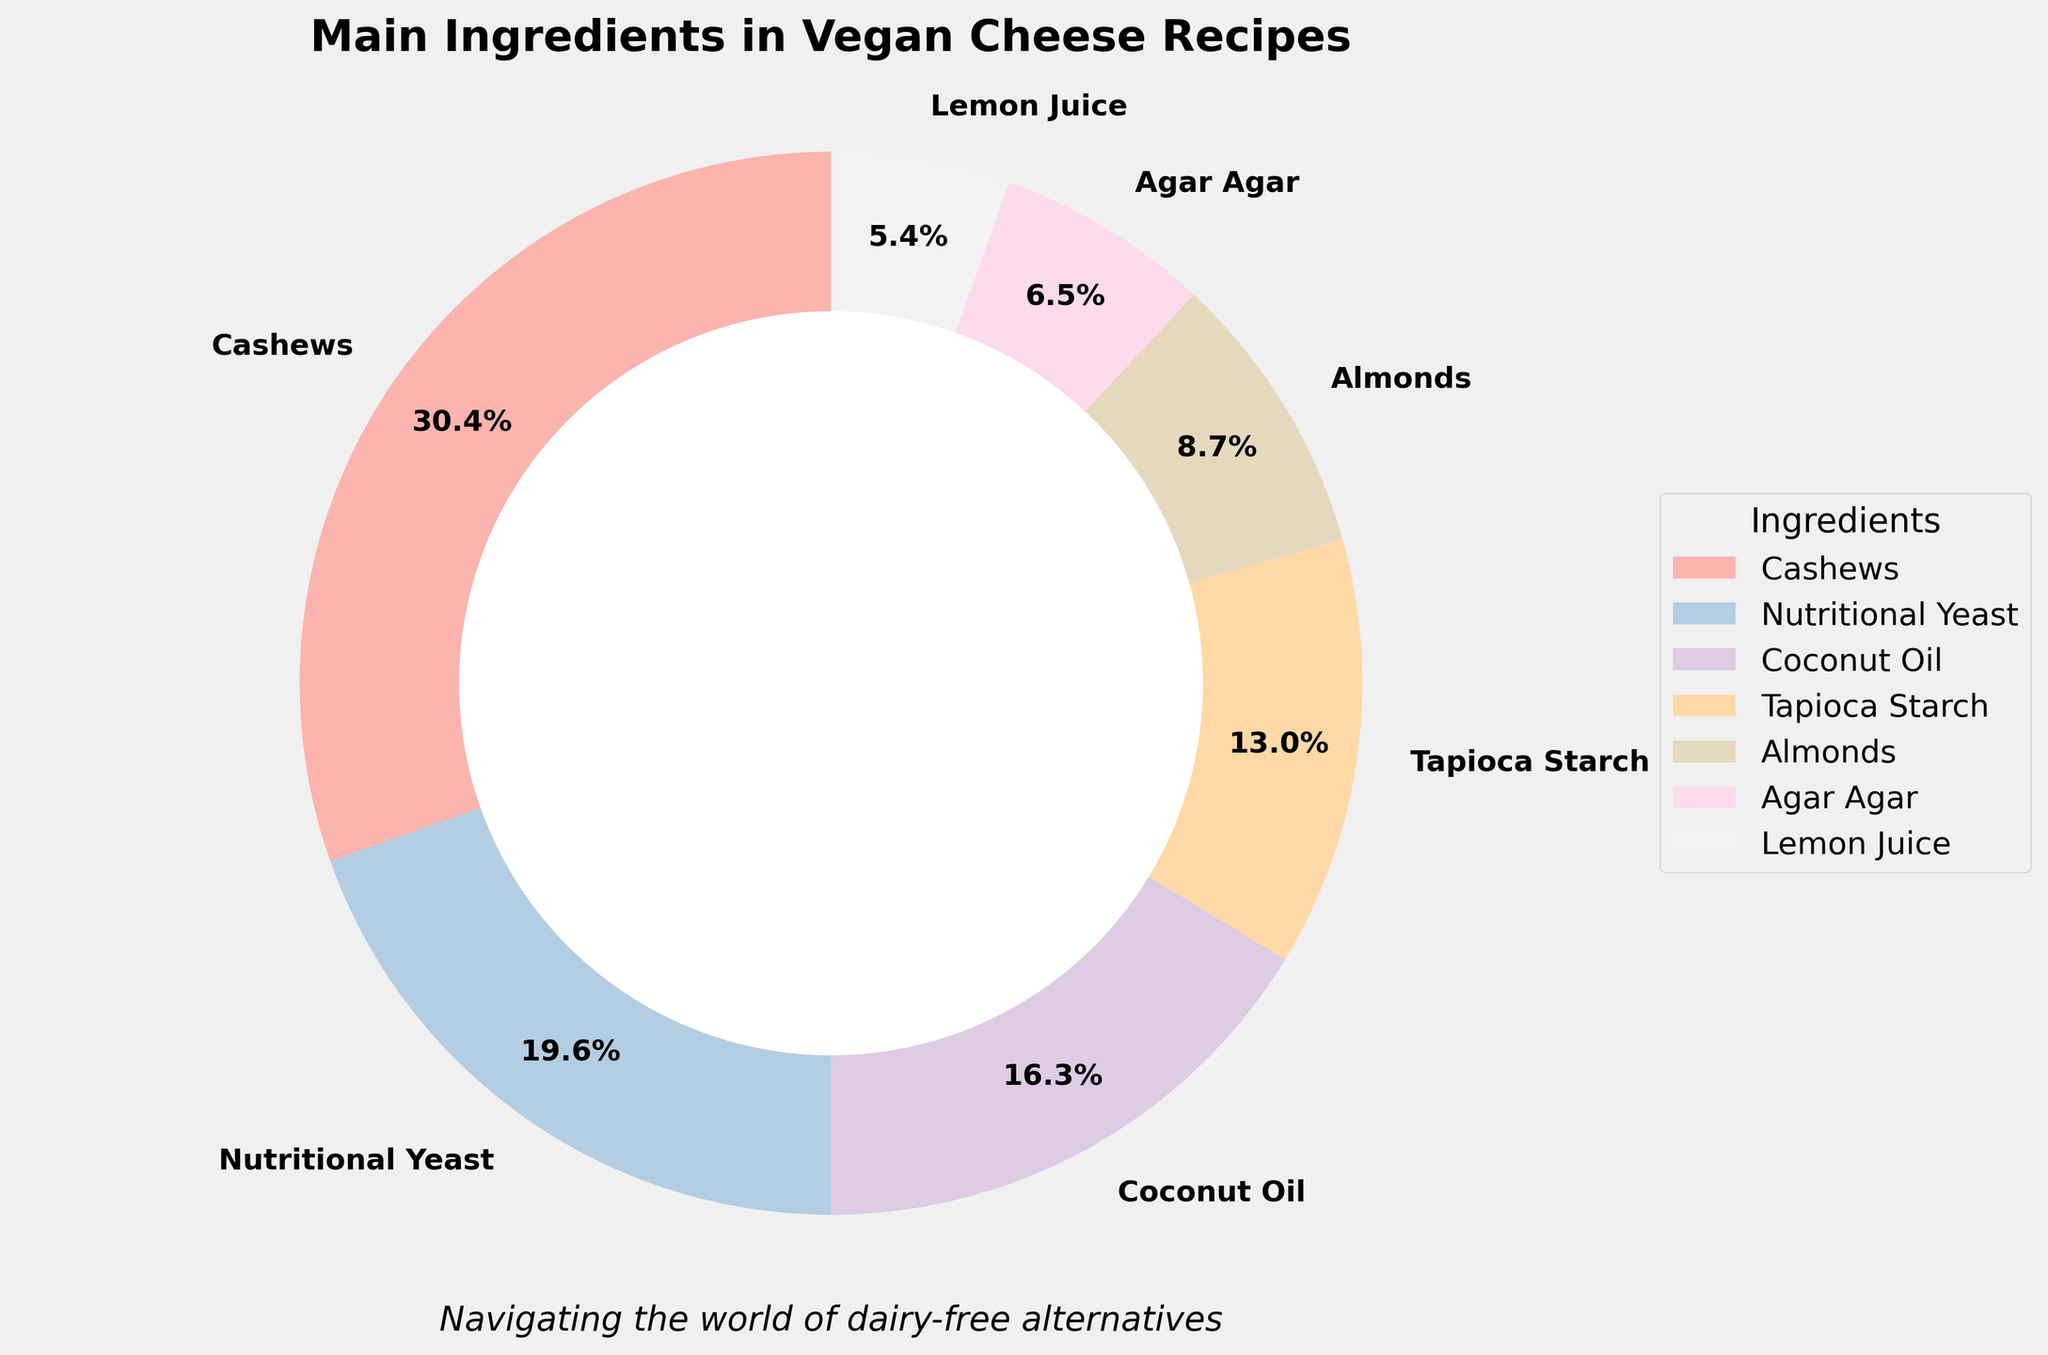What percentage of the ingredients have a contribution of 5% or more? To determine this, we need to check the provided percentages of each ingredient in the figure. The ingredients that contribute 5% or more are: Cashews (28%), Nutritional Yeast (18%), Coconut Oil (15%), Tapioca Starch (12%), and Almonds (8%). Adding these up gives us 5 ingredients. The total number of unique ingredients is 12, so 5 out of 12 ingredients have a contribution of more than 5%.
Answer: 5 out of 12 What is the most used ingredient in vegan cheese recipes? By looking at the pie chart, the ingredient with the largest percentage slice is the most used. Cashews have the largest slice at 28%.
Answer: Cashews Which ingredients have the smallest slices, and what is their percentage? By observing the smallest slices in the pie chart, we see that Garlic Powder, Onion Powder, and Turmeric each have slices representing 1% of the total.
Answer: Garlic Powder, Onion Powder, Turmeric (1% each) How many ingredients contribute a percentage between 10% and 20%? We need to identify the slices that fall within this range. Both Nutritional Yeast (18%) and Tapioca Starch (12%) fall within this range.
Answer: Two ingredients Between Cashews and Coconut Oil, which ingredient contributes less and by how much? Cashews contribute 28%, and Coconut Oil contributes 15%. Subtracting the two values (28% - 15%) gives us the difference.
Answer: Coconut Oil contributes 13% less If we combine the percentages of Almonds and Agar Agar, will they exceed the percentage of Nutritional Yeast alone? Almonds contribute 8% and Agar Agar 6%, adding these together gives 14%. Nutritional Yeast alone contributes 18%. Therefore, 14% does not exceed 18%.
Answer: No What percentage of vegan cheese recipes do the top three ingredients make up? The top three ingredients are Cashews (28%), Nutritional Yeast (18%), and Coconut Oil (15%). Adding these gives us 28% + 18% + 15% = 61%.
Answer: 61% If an ingredient is picked at random from the chart, what is the probability that it contributes less than 10%? We need to count the number of ingredients contributing less than 10%: Almonds (8%), Agar Agar (6%), Lemon Juice (5%), Miso Paste (3%), Apple Cider Vinegar (2%), Garlic Powder (1%), Onion Powder (1%), Turmeric (1%). This gives us 8 ingredients out of a total of 12.
Answer: 8 out of 12 or 2/3 What is the total contribution percentage of ingredients not shown in the chart? The provided code filters out ingredients less than 5%, which are still calculated in the total. Ingredients below 5% are Lemon Juice (5%), Miso Paste (3%), Apple Cider Vinegar (2%), Garlic Powder (1%), Onion Powder (1%), and Turmeric (1%). Summing these gives us 13%.
Answer: 13% What is the average percentage contribution of the ingredients included in the pie chart? To find the average, we add up the percentages of the ingredients that are shown (Cashews: 28%, Nutritional Yeast: 18%, Coconut Oil: 15%, Tapioca Starch: 12%, Almonds: 8%, Agar Agar: 6%, Lemon Juice: 5%) and then divide by the number of those ingredients (7). The sum is 28 + 18 + 15 + 12 + 8 + 6 + 5 = 92. Dividing 92 by 7 gives us approximately 13.14%.
Answer: 13.14% 